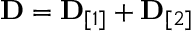Convert formula to latex. <formula><loc_0><loc_0><loc_500><loc_500>\begin{array} { r } { { D } = { D } _ { [ 1 ] } + { D } _ { [ 2 ] } } \end{array}</formula> 